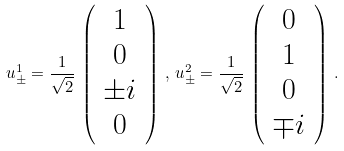Convert formula to latex. <formula><loc_0><loc_0><loc_500><loc_500>u _ { \pm } ^ { 1 } = \frac { 1 } { \sqrt { 2 } } \, \left ( \begin{array} { c } 1 \\ 0 \\ \pm i \\ 0 \end{array} \right ) \, , \, u _ { \pm } ^ { 2 } = \frac { 1 } { \sqrt { 2 } } \, \left ( \begin{array} { c } 0 \\ 1 \\ 0 \\ \mp i \end{array} \right ) \, .</formula> 